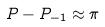<formula> <loc_0><loc_0><loc_500><loc_500>P - P _ { - 1 } \approx \pi</formula> 